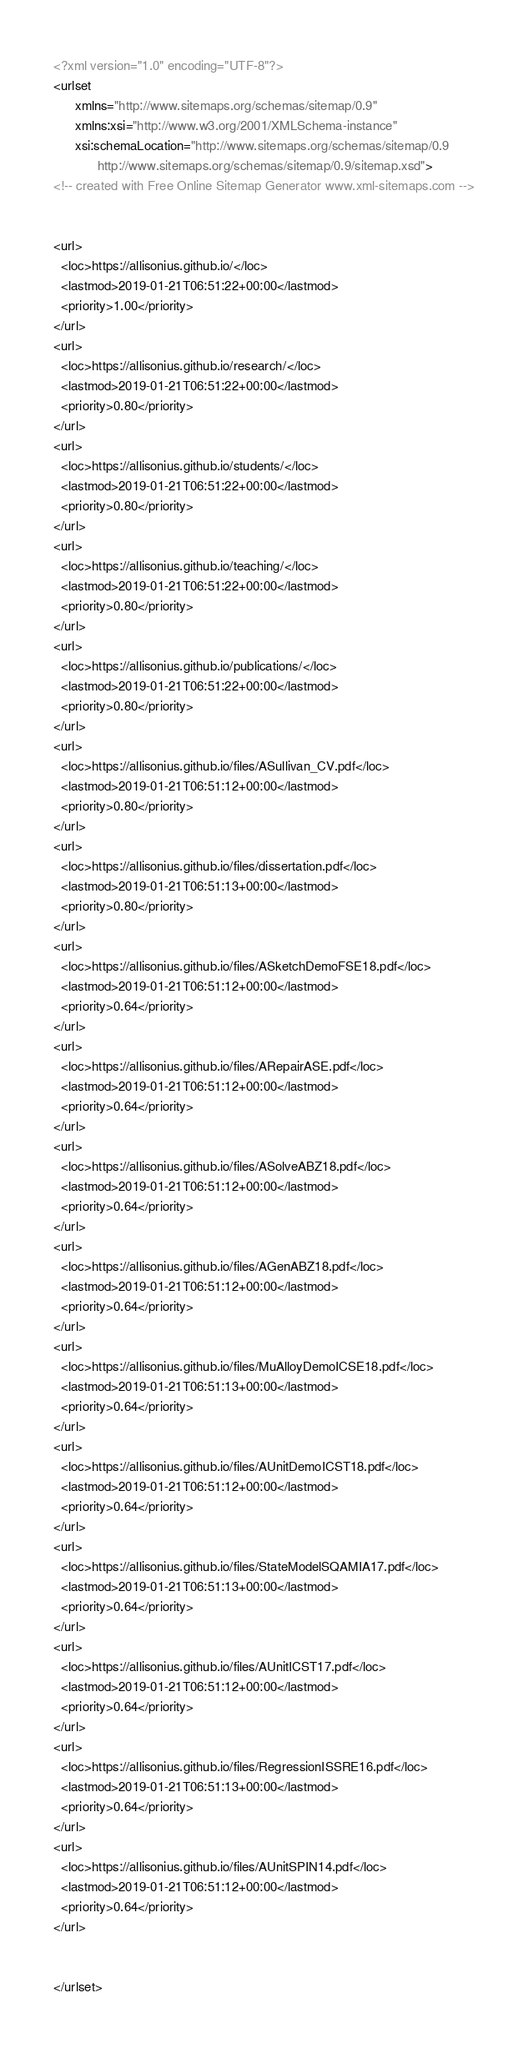<code> <loc_0><loc_0><loc_500><loc_500><_XML_><?xml version="1.0" encoding="UTF-8"?>
<urlset
      xmlns="http://www.sitemaps.org/schemas/sitemap/0.9"
      xmlns:xsi="http://www.w3.org/2001/XMLSchema-instance"
      xsi:schemaLocation="http://www.sitemaps.org/schemas/sitemap/0.9
            http://www.sitemaps.org/schemas/sitemap/0.9/sitemap.xsd">
<!-- created with Free Online Sitemap Generator www.xml-sitemaps.com -->


<url>
  <loc>https://allisonius.github.io/</loc>
  <lastmod>2019-01-21T06:51:22+00:00</lastmod>
  <priority>1.00</priority>
</url>
<url>
  <loc>https://allisonius.github.io/research/</loc>
  <lastmod>2019-01-21T06:51:22+00:00</lastmod>
  <priority>0.80</priority>
</url>
<url>
  <loc>https://allisonius.github.io/students/</loc>
  <lastmod>2019-01-21T06:51:22+00:00</lastmod>
  <priority>0.80</priority>
</url>
<url>
  <loc>https://allisonius.github.io/teaching/</loc>
  <lastmod>2019-01-21T06:51:22+00:00</lastmod>
  <priority>0.80</priority>
</url>
<url>
  <loc>https://allisonius.github.io/publications/</loc>
  <lastmod>2019-01-21T06:51:22+00:00</lastmod>
  <priority>0.80</priority>
</url>
<url>
  <loc>https://allisonius.github.io/files/ASullivan_CV.pdf</loc>
  <lastmod>2019-01-21T06:51:12+00:00</lastmod>
  <priority>0.80</priority>
</url>
<url>
  <loc>https://allisonius.github.io/files/dissertation.pdf</loc>
  <lastmod>2019-01-21T06:51:13+00:00</lastmod>
  <priority>0.80</priority>
</url>
<url>
  <loc>https://allisonius.github.io/files/ASketchDemoFSE18.pdf</loc>
  <lastmod>2019-01-21T06:51:12+00:00</lastmod>
  <priority>0.64</priority>
</url>
<url>
  <loc>https://allisonius.github.io/files/ARepairASE.pdf</loc>
  <lastmod>2019-01-21T06:51:12+00:00</lastmod>
  <priority>0.64</priority>
</url>
<url>
  <loc>https://allisonius.github.io/files/ASolveABZ18.pdf</loc>
  <lastmod>2019-01-21T06:51:12+00:00</lastmod>
  <priority>0.64</priority>
</url>
<url>
  <loc>https://allisonius.github.io/files/AGenABZ18.pdf</loc>
  <lastmod>2019-01-21T06:51:12+00:00</lastmod>
  <priority>0.64</priority>
</url>
<url>
  <loc>https://allisonius.github.io/files/MuAlloyDemoICSE18.pdf</loc>
  <lastmod>2019-01-21T06:51:13+00:00</lastmod>
  <priority>0.64</priority>
</url>
<url>
  <loc>https://allisonius.github.io/files/AUnitDemoICST18.pdf</loc>
  <lastmod>2019-01-21T06:51:12+00:00</lastmod>
  <priority>0.64</priority>
</url>
<url>
  <loc>https://allisonius.github.io/files/StateModelSQAMIA17.pdf</loc>
  <lastmod>2019-01-21T06:51:13+00:00</lastmod>
  <priority>0.64</priority>
</url>
<url>
  <loc>https://allisonius.github.io/files/AUnitICST17.pdf</loc>
  <lastmod>2019-01-21T06:51:12+00:00</lastmod>
  <priority>0.64</priority>
</url>
<url>
  <loc>https://allisonius.github.io/files/RegressionISSRE16.pdf</loc>
  <lastmod>2019-01-21T06:51:13+00:00</lastmod>
  <priority>0.64</priority>
</url>
<url>
  <loc>https://allisonius.github.io/files/AUnitSPIN14.pdf</loc>
  <lastmod>2019-01-21T06:51:12+00:00</lastmod>
  <priority>0.64</priority>
</url>


</urlset></code> 